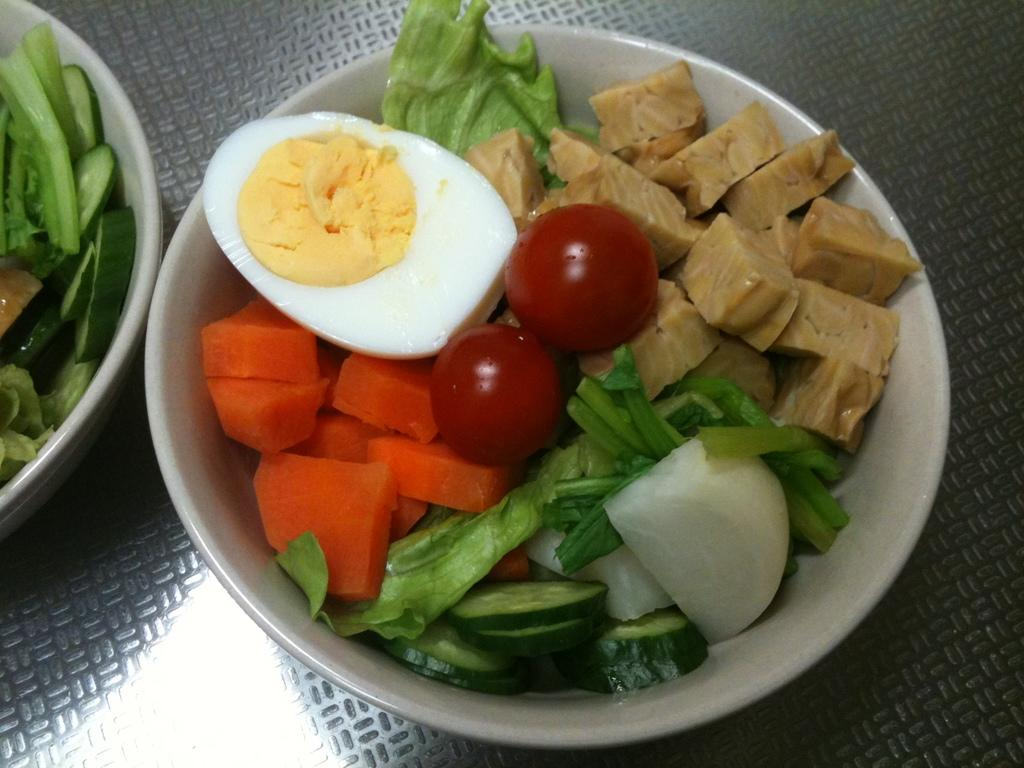What objects are on the metal surface in the image? There are bowls on a metal surface in the image. What is inside the bowls? There are food items in the bowls. What type of event is taking place in the image? There is no indication of an event taking place in the image; it simply shows bowls with food items on a metal surface. What type of care is being provided to the rake in the image? There is no rake present in the image, so it is not possible to discuss any care being provided to it. 